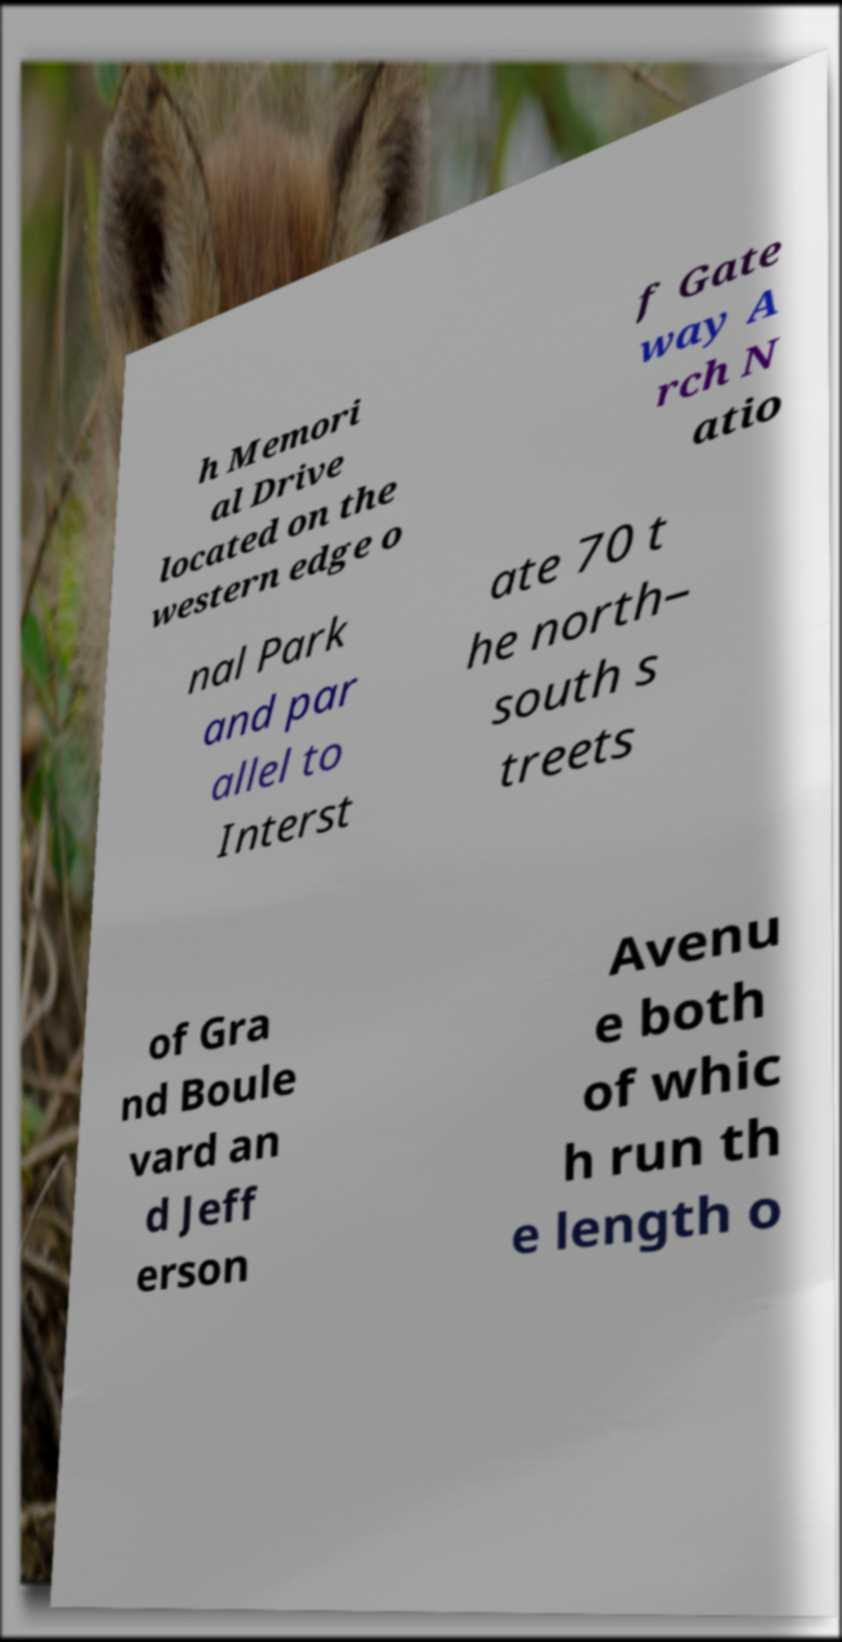Can you accurately transcribe the text from the provided image for me? h Memori al Drive located on the western edge o f Gate way A rch N atio nal Park and par allel to Interst ate 70 t he north– south s treets of Gra nd Boule vard an d Jeff erson Avenu e both of whic h run th e length o 